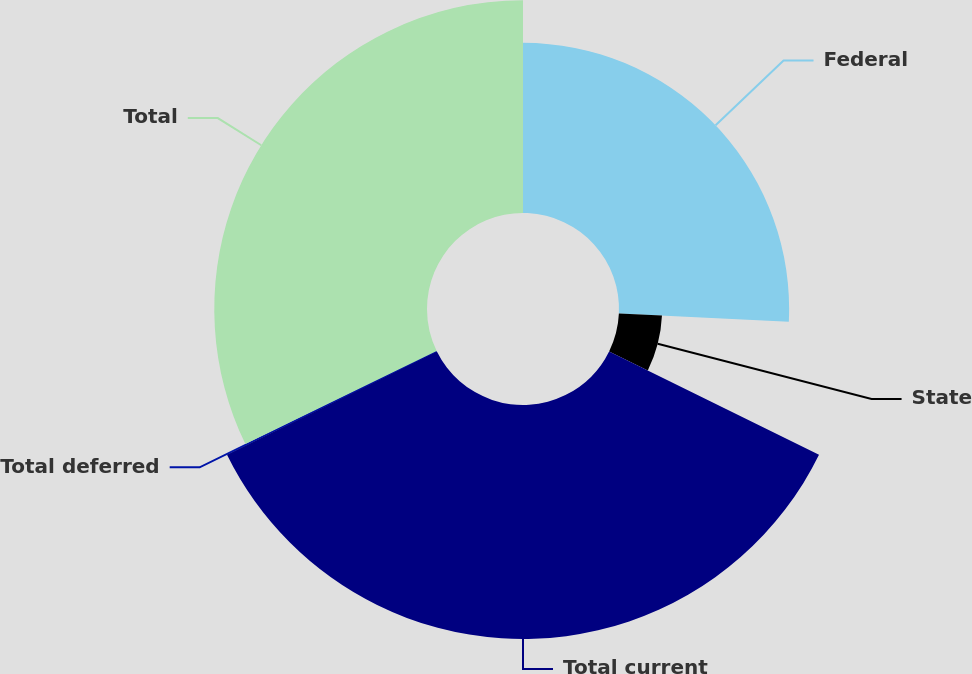<chart> <loc_0><loc_0><loc_500><loc_500><pie_chart><fcel>Federal<fcel>State<fcel>Total current<fcel>Total deferred<fcel>Total<nl><fcel>25.76%<fcel>6.53%<fcel>35.43%<fcel>0.08%<fcel>32.21%<nl></chart> 